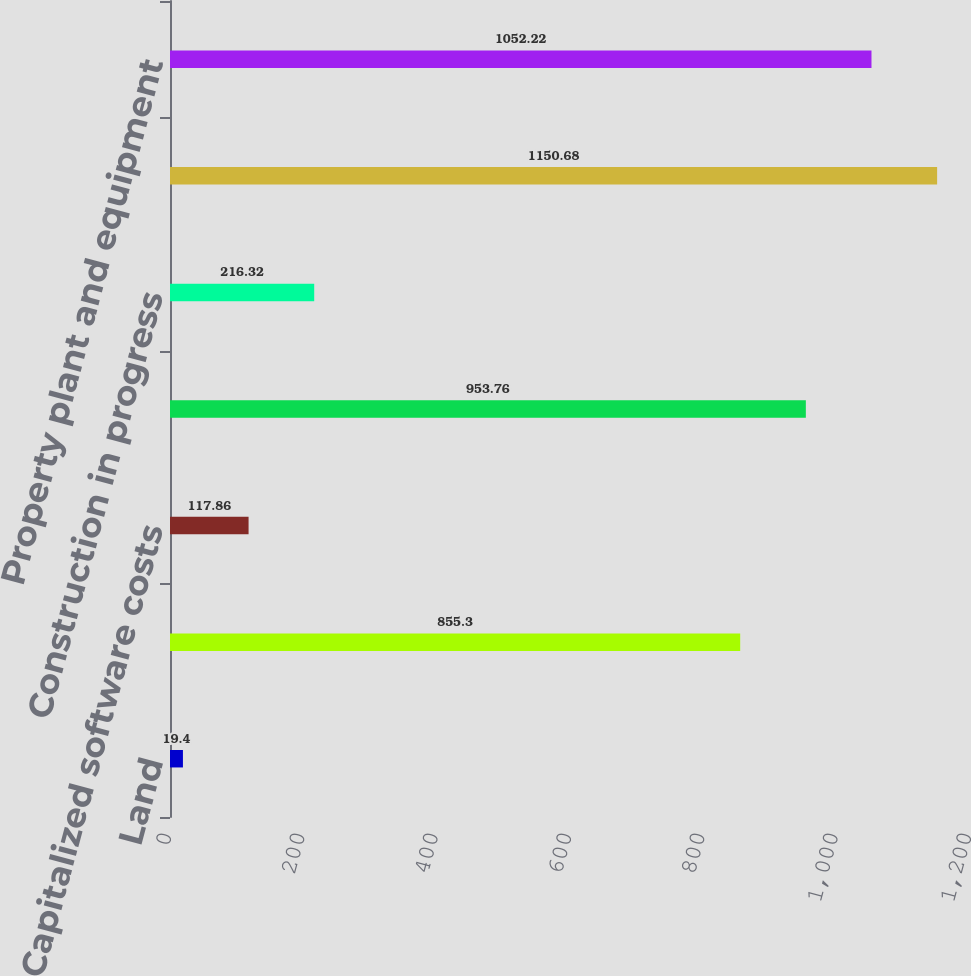Convert chart to OTSL. <chart><loc_0><loc_0><loc_500><loc_500><bar_chart><fcel>Land<fcel>Building and equipment<fcel>Capitalized software costs<fcel>Instruments<fcel>Construction in progress<fcel>Accumulated depreciation<fcel>Property plant and equipment<nl><fcel>19.4<fcel>855.3<fcel>117.86<fcel>953.76<fcel>216.32<fcel>1150.68<fcel>1052.22<nl></chart> 